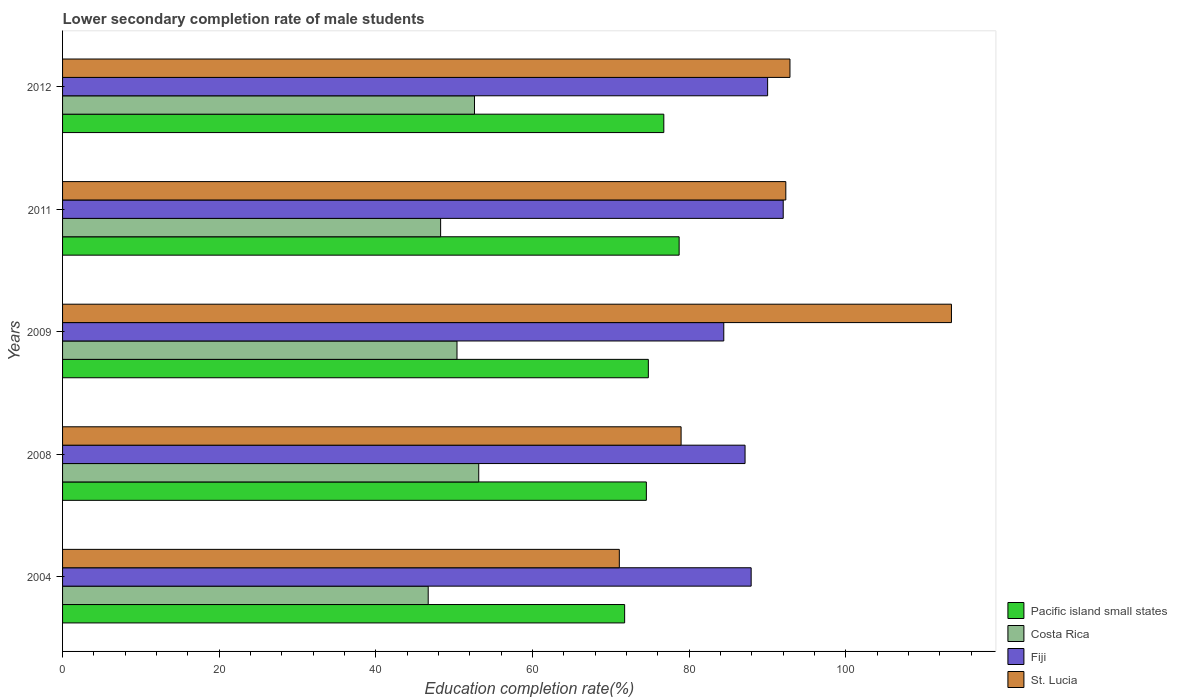How many different coloured bars are there?
Ensure brevity in your answer.  4. How many groups of bars are there?
Offer a very short reply. 5. How many bars are there on the 4th tick from the top?
Your response must be concise. 4. How many bars are there on the 2nd tick from the bottom?
Your answer should be very brief. 4. In how many cases, is the number of bars for a given year not equal to the number of legend labels?
Provide a short and direct response. 0. What is the lower secondary completion rate of male students in Fiji in 2004?
Your response must be concise. 87.9. Across all years, what is the maximum lower secondary completion rate of male students in St. Lucia?
Your answer should be very brief. 113.47. Across all years, what is the minimum lower secondary completion rate of male students in St. Lucia?
Your answer should be compact. 71.07. What is the total lower secondary completion rate of male students in Costa Rica in the graph?
Your answer should be very brief. 251. What is the difference between the lower secondary completion rate of male students in Fiji in 2009 and that in 2011?
Keep it short and to the point. -7.59. What is the difference between the lower secondary completion rate of male students in Fiji in 2004 and the lower secondary completion rate of male students in St. Lucia in 2012?
Your answer should be compact. -4.95. What is the average lower secondary completion rate of male students in Pacific island small states per year?
Provide a succinct answer. 75.3. In the year 2004, what is the difference between the lower secondary completion rate of male students in St. Lucia and lower secondary completion rate of male students in Costa Rica?
Your answer should be compact. 24.4. What is the ratio of the lower secondary completion rate of male students in Fiji in 2004 to that in 2008?
Your answer should be very brief. 1.01. Is the lower secondary completion rate of male students in Pacific island small states in 2008 less than that in 2009?
Your response must be concise. Yes. Is the difference between the lower secondary completion rate of male students in St. Lucia in 2009 and 2011 greater than the difference between the lower secondary completion rate of male students in Costa Rica in 2009 and 2011?
Provide a short and direct response. Yes. What is the difference between the highest and the second highest lower secondary completion rate of male students in Costa Rica?
Ensure brevity in your answer.  0.54. What is the difference between the highest and the lowest lower secondary completion rate of male students in St. Lucia?
Ensure brevity in your answer.  42.4. In how many years, is the lower secondary completion rate of male students in Fiji greater than the average lower secondary completion rate of male students in Fiji taken over all years?
Offer a very short reply. 2. What does the 4th bar from the bottom in 2008 represents?
Provide a short and direct response. St. Lucia. How many years are there in the graph?
Your answer should be compact. 5. Does the graph contain grids?
Your answer should be very brief. No. Where does the legend appear in the graph?
Provide a succinct answer. Bottom right. How many legend labels are there?
Provide a short and direct response. 4. How are the legend labels stacked?
Offer a terse response. Vertical. What is the title of the graph?
Your answer should be compact. Lower secondary completion rate of male students. Does "Sub-Saharan Africa (developing only)" appear as one of the legend labels in the graph?
Offer a terse response. No. What is the label or title of the X-axis?
Your answer should be very brief. Education completion rate(%). What is the Education completion rate(%) in Pacific island small states in 2004?
Offer a terse response. 71.75. What is the Education completion rate(%) in Costa Rica in 2004?
Your answer should be very brief. 46.68. What is the Education completion rate(%) in Fiji in 2004?
Provide a short and direct response. 87.9. What is the Education completion rate(%) of St. Lucia in 2004?
Give a very brief answer. 71.07. What is the Education completion rate(%) of Pacific island small states in 2008?
Your answer should be compact. 74.52. What is the Education completion rate(%) in Costa Rica in 2008?
Give a very brief answer. 53.13. What is the Education completion rate(%) in Fiji in 2008?
Offer a very short reply. 87.12. What is the Education completion rate(%) of St. Lucia in 2008?
Keep it short and to the point. 78.96. What is the Education completion rate(%) in Pacific island small states in 2009?
Make the answer very short. 74.78. What is the Education completion rate(%) of Costa Rica in 2009?
Offer a terse response. 50.35. What is the Education completion rate(%) of Fiji in 2009?
Provide a succinct answer. 84.41. What is the Education completion rate(%) of St. Lucia in 2009?
Offer a terse response. 113.47. What is the Education completion rate(%) of Pacific island small states in 2011?
Your response must be concise. 78.71. What is the Education completion rate(%) of Costa Rica in 2011?
Offer a terse response. 48.26. What is the Education completion rate(%) of Fiji in 2011?
Your response must be concise. 92. What is the Education completion rate(%) of St. Lucia in 2011?
Make the answer very short. 92.33. What is the Education completion rate(%) in Pacific island small states in 2012?
Offer a terse response. 76.75. What is the Education completion rate(%) of Costa Rica in 2012?
Provide a succinct answer. 52.58. What is the Education completion rate(%) of Fiji in 2012?
Keep it short and to the point. 90. What is the Education completion rate(%) of St. Lucia in 2012?
Ensure brevity in your answer.  92.86. Across all years, what is the maximum Education completion rate(%) of Pacific island small states?
Your answer should be very brief. 78.71. Across all years, what is the maximum Education completion rate(%) in Costa Rica?
Your response must be concise. 53.13. Across all years, what is the maximum Education completion rate(%) in Fiji?
Your answer should be compact. 92. Across all years, what is the maximum Education completion rate(%) of St. Lucia?
Provide a succinct answer. 113.47. Across all years, what is the minimum Education completion rate(%) of Pacific island small states?
Make the answer very short. 71.75. Across all years, what is the minimum Education completion rate(%) in Costa Rica?
Your response must be concise. 46.68. Across all years, what is the minimum Education completion rate(%) of Fiji?
Your answer should be compact. 84.41. Across all years, what is the minimum Education completion rate(%) of St. Lucia?
Offer a very short reply. 71.07. What is the total Education completion rate(%) of Pacific island small states in the graph?
Make the answer very short. 376.51. What is the total Education completion rate(%) of Costa Rica in the graph?
Keep it short and to the point. 251. What is the total Education completion rate(%) in Fiji in the graph?
Ensure brevity in your answer.  441.43. What is the total Education completion rate(%) of St. Lucia in the graph?
Ensure brevity in your answer.  448.69. What is the difference between the Education completion rate(%) of Pacific island small states in 2004 and that in 2008?
Offer a very short reply. -2.77. What is the difference between the Education completion rate(%) of Costa Rica in 2004 and that in 2008?
Your response must be concise. -6.45. What is the difference between the Education completion rate(%) in Fiji in 2004 and that in 2008?
Your answer should be compact. 0.78. What is the difference between the Education completion rate(%) of St. Lucia in 2004 and that in 2008?
Offer a very short reply. -7.89. What is the difference between the Education completion rate(%) of Pacific island small states in 2004 and that in 2009?
Make the answer very short. -3.03. What is the difference between the Education completion rate(%) in Costa Rica in 2004 and that in 2009?
Offer a terse response. -3.67. What is the difference between the Education completion rate(%) in Fiji in 2004 and that in 2009?
Your response must be concise. 3.49. What is the difference between the Education completion rate(%) of St. Lucia in 2004 and that in 2009?
Make the answer very short. -42.4. What is the difference between the Education completion rate(%) of Pacific island small states in 2004 and that in 2011?
Provide a short and direct response. -6.96. What is the difference between the Education completion rate(%) in Costa Rica in 2004 and that in 2011?
Provide a succinct answer. -1.59. What is the difference between the Education completion rate(%) in Fiji in 2004 and that in 2011?
Make the answer very short. -4.09. What is the difference between the Education completion rate(%) of St. Lucia in 2004 and that in 2011?
Your answer should be compact. -21.25. What is the difference between the Education completion rate(%) of Pacific island small states in 2004 and that in 2012?
Give a very brief answer. -5. What is the difference between the Education completion rate(%) in Costa Rica in 2004 and that in 2012?
Provide a succinct answer. -5.91. What is the difference between the Education completion rate(%) in Fiji in 2004 and that in 2012?
Make the answer very short. -2.1. What is the difference between the Education completion rate(%) in St. Lucia in 2004 and that in 2012?
Keep it short and to the point. -21.78. What is the difference between the Education completion rate(%) in Pacific island small states in 2008 and that in 2009?
Offer a very short reply. -0.25. What is the difference between the Education completion rate(%) of Costa Rica in 2008 and that in 2009?
Your answer should be compact. 2.78. What is the difference between the Education completion rate(%) of Fiji in 2008 and that in 2009?
Your response must be concise. 2.71. What is the difference between the Education completion rate(%) in St. Lucia in 2008 and that in 2009?
Provide a succinct answer. -34.51. What is the difference between the Education completion rate(%) in Pacific island small states in 2008 and that in 2011?
Your response must be concise. -4.19. What is the difference between the Education completion rate(%) in Costa Rica in 2008 and that in 2011?
Ensure brevity in your answer.  4.86. What is the difference between the Education completion rate(%) in Fiji in 2008 and that in 2011?
Your answer should be compact. -4.87. What is the difference between the Education completion rate(%) in St. Lucia in 2008 and that in 2011?
Your response must be concise. -13.37. What is the difference between the Education completion rate(%) in Pacific island small states in 2008 and that in 2012?
Your answer should be compact. -2.23. What is the difference between the Education completion rate(%) in Costa Rica in 2008 and that in 2012?
Make the answer very short. 0.54. What is the difference between the Education completion rate(%) of Fiji in 2008 and that in 2012?
Your answer should be compact. -2.88. What is the difference between the Education completion rate(%) of St. Lucia in 2008 and that in 2012?
Your response must be concise. -13.9. What is the difference between the Education completion rate(%) in Pacific island small states in 2009 and that in 2011?
Provide a succinct answer. -3.93. What is the difference between the Education completion rate(%) in Costa Rica in 2009 and that in 2011?
Provide a succinct answer. 2.09. What is the difference between the Education completion rate(%) in Fiji in 2009 and that in 2011?
Your answer should be very brief. -7.59. What is the difference between the Education completion rate(%) of St. Lucia in 2009 and that in 2011?
Give a very brief answer. 21.15. What is the difference between the Education completion rate(%) of Pacific island small states in 2009 and that in 2012?
Offer a terse response. -1.98. What is the difference between the Education completion rate(%) of Costa Rica in 2009 and that in 2012?
Provide a short and direct response. -2.23. What is the difference between the Education completion rate(%) of Fiji in 2009 and that in 2012?
Provide a short and direct response. -5.6. What is the difference between the Education completion rate(%) of St. Lucia in 2009 and that in 2012?
Your answer should be compact. 20.61. What is the difference between the Education completion rate(%) of Pacific island small states in 2011 and that in 2012?
Your answer should be very brief. 1.96. What is the difference between the Education completion rate(%) of Costa Rica in 2011 and that in 2012?
Ensure brevity in your answer.  -4.32. What is the difference between the Education completion rate(%) of Fiji in 2011 and that in 2012?
Ensure brevity in your answer.  1.99. What is the difference between the Education completion rate(%) of St. Lucia in 2011 and that in 2012?
Your response must be concise. -0.53. What is the difference between the Education completion rate(%) of Pacific island small states in 2004 and the Education completion rate(%) of Costa Rica in 2008?
Offer a terse response. 18.62. What is the difference between the Education completion rate(%) in Pacific island small states in 2004 and the Education completion rate(%) in Fiji in 2008?
Give a very brief answer. -15.37. What is the difference between the Education completion rate(%) of Pacific island small states in 2004 and the Education completion rate(%) of St. Lucia in 2008?
Your answer should be very brief. -7.21. What is the difference between the Education completion rate(%) in Costa Rica in 2004 and the Education completion rate(%) in Fiji in 2008?
Provide a succinct answer. -40.45. What is the difference between the Education completion rate(%) of Costa Rica in 2004 and the Education completion rate(%) of St. Lucia in 2008?
Provide a short and direct response. -32.28. What is the difference between the Education completion rate(%) of Fiji in 2004 and the Education completion rate(%) of St. Lucia in 2008?
Ensure brevity in your answer.  8.94. What is the difference between the Education completion rate(%) of Pacific island small states in 2004 and the Education completion rate(%) of Costa Rica in 2009?
Offer a very short reply. 21.4. What is the difference between the Education completion rate(%) in Pacific island small states in 2004 and the Education completion rate(%) in Fiji in 2009?
Keep it short and to the point. -12.66. What is the difference between the Education completion rate(%) of Pacific island small states in 2004 and the Education completion rate(%) of St. Lucia in 2009?
Give a very brief answer. -41.72. What is the difference between the Education completion rate(%) of Costa Rica in 2004 and the Education completion rate(%) of Fiji in 2009?
Provide a short and direct response. -37.73. What is the difference between the Education completion rate(%) in Costa Rica in 2004 and the Education completion rate(%) in St. Lucia in 2009?
Offer a terse response. -66.8. What is the difference between the Education completion rate(%) in Fiji in 2004 and the Education completion rate(%) in St. Lucia in 2009?
Ensure brevity in your answer.  -25.57. What is the difference between the Education completion rate(%) in Pacific island small states in 2004 and the Education completion rate(%) in Costa Rica in 2011?
Offer a terse response. 23.49. What is the difference between the Education completion rate(%) in Pacific island small states in 2004 and the Education completion rate(%) in Fiji in 2011?
Offer a terse response. -20.24. What is the difference between the Education completion rate(%) of Pacific island small states in 2004 and the Education completion rate(%) of St. Lucia in 2011?
Your response must be concise. -20.57. What is the difference between the Education completion rate(%) in Costa Rica in 2004 and the Education completion rate(%) in Fiji in 2011?
Offer a very short reply. -45.32. What is the difference between the Education completion rate(%) in Costa Rica in 2004 and the Education completion rate(%) in St. Lucia in 2011?
Provide a succinct answer. -45.65. What is the difference between the Education completion rate(%) of Fiji in 2004 and the Education completion rate(%) of St. Lucia in 2011?
Give a very brief answer. -4.42. What is the difference between the Education completion rate(%) of Pacific island small states in 2004 and the Education completion rate(%) of Costa Rica in 2012?
Offer a very short reply. 19.17. What is the difference between the Education completion rate(%) of Pacific island small states in 2004 and the Education completion rate(%) of Fiji in 2012?
Provide a succinct answer. -18.25. What is the difference between the Education completion rate(%) in Pacific island small states in 2004 and the Education completion rate(%) in St. Lucia in 2012?
Provide a short and direct response. -21.11. What is the difference between the Education completion rate(%) in Costa Rica in 2004 and the Education completion rate(%) in Fiji in 2012?
Ensure brevity in your answer.  -43.33. What is the difference between the Education completion rate(%) in Costa Rica in 2004 and the Education completion rate(%) in St. Lucia in 2012?
Your answer should be compact. -46.18. What is the difference between the Education completion rate(%) of Fiji in 2004 and the Education completion rate(%) of St. Lucia in 2012?
Ensure brevity in your answer.  -4.95. What is the difference between the Education completion rate(%) in Pacific island small states in 2008 and the Education completion rate(%) in Costa Rica in 2009?
Your response must be concise. 24.17. What is the difference between the Education completion rate(%) of Pacific island small states in 2008 and the Education completion rate(%) of Fiji in 2009?
Your answer should be compact. -9.89. What is the difference between the Education completion rate(%) in Pacific island small states in 2008 and the Education completion rate(%) in St. Lucia in 2009?
Keep it short and to the point. -38.95. What is the difference between the Education completion rate(%) of Costa Rica in 2008 and the Education completion rate(%) of Fiji in 2009?
Your answer should be very brief. -31.28. What is the difference between the Education completion rate(%) in Costa Rica in 2008 and the Education completion rate(%) in St. Lucia in 2009?
Your answer should be very brief. -60.34. What is the difference between the Education completion rate(%) in Fiji in 2008 and the Education completion rate(%) in St. Lucia in 2009?
Your response must be concise. -26.35. What is the difference between the Education completion rate(%) of Pacific island small states in 2008 and the Education completion rate(%) of Costa Rica in 2011?
Ensure brevity in your answer.  26.26. What is the difference between the Education completion rate(%) in Pacific island small states in 2008 and the Education completion rate(%) in Fiji in 2011?
Offer a terse response. -17.47. What is the difference between the Education completion rate(%) of Pacific island small states in 2008 and the Education completion rate(%) of St. Lucia in 2011?
Provide a succinct answer. -17.8. What is the difference between the Education completion rate(%) in Costa Rica in 2008 and the Education completion rate(%) in Fiji in 2011?
Provide a succinct answer. -38.87. What is the difference between the Education completion rate(%) of Costa Rica in 2008 and the Education completion rate(%) of St. Lucia in 2011?
Provide a short and direct response. -39.2. What is the difference between the Education completion rate(%) of Fiji in 2008 and the Education completion rate(%) of St. Lucia in 2011?
Provide a succinct answer. -5.2. What is the difference between the Education completion rate(%) in Pacific island small states in 2008 and the Education completion rate(%) in Costa Rica in 2012?
Offer a terse response. 21.94. What is the difference between the Education completion rate(%) of Pacific island small states in 2008 and the Education completion rate(%) of Fiji in 2012?
Offer a terse response. -15.48. What is the difference between the Education completion rate(%) in Pacific island small states in 2008 and the Education completion rate(%) in St. Lucia in 2012?
Your answer should be compact. -18.33. What is the difference between the Education completion rate(%) in Costa Rica in 2008 and the Education completion rate(%) in Fiji in 2012?
Ensure brevity in your answer.  -36.88. What is the difference between the Education completion rate(%) in Costa Rica in 2008 and the Education completion rate(%) in St. Lucia in 2012?
Provide a succinct answer. -39.73. What is the difference between the Education completion rate(%) in Fiji in 2008 and the Education completion rate(%) in St. Lucia in 2012?
Give a very brief answer. -5.73. What is the difference between the Education completion rate(%) in Pacific island small states in 2009 and the Education completion rate(%) in Costa Rica in 2011?
Your answer should be very brief. 26.52. What is the difference between the Education completion rate(%) in Pacific island small states in 2009 and the Education completion rate(%) in Fiji in 2011?
Ensure brevity in your answer.  -17.22. What is the difference between the Education completion rate(%) of Pacific island small states in 2009 and the Education completion rate(%) of St. Lucia in 2011?
Your response must be concise. -17.55. What is the difference between the Education completion rate(%) in Costa Rica in 2009 and the Education completion rate(%) in Fiji in 2011?
Keep it short and to the point. -41.64. What is the difference between the Education completion rate(%) of Costa Rica in 2009 and the Education completion rate(%) of St. Lucia in 2011?
Ensure brevity in your answer.  -41.97. What is the difference between the Education completion rate(%) of Fiji in 2009 and the Education completion rate(%) of St. Lucia in 2011?
Provide a succinct answer. -7.92. What is the difference between the Education completion rate(%) of Pacific island small states in 2009 and the Education completion rate(%) of Costa Rica in 2012?
Your answer should be compact. 22.19. What is the difference between the Education completion rate(%) of Pacific island small states in 2009 and the Education completion rate(%) of Fiji in 2012?
Give a very brief answer. -15.23. What is the difference between the Education completion rate(%) in Pacific island small states in 2009 and the Education completion rate(%) in St. Lucia in 2012?
Provide a succinct answer. -18.08. What is the difference between the Education completion rate(%) of Costa Rica in 2009 and the Education completion rate(%) of Fiji in 2012?
Offer a very short reply. -39.65. What is the difference between the Education completion rate(%) in Costa Rica in 2009 and the Education completion rate(%) in St. Lucia in 2012?
Keep it short and to the point. -42.51. What is the difference between the Education completion rate(%) of Fiji in 2009 and the Education completion rate(%) of St. Lucia in 2012?
Offer a terse response. -8.45. What is the difference between the Education completion rate(%) in Pacific island small states in 2011 and the Education completion rate(%) in Costa Rica in 2012?
Your answer should be compact. 26.12. What is the difference between the Education completion rate(%) in Pacific island small states in 2011 and the Education completion rate(%) in Fiji in 2012?
Keep it short and to the point. -11.29. What is the difference between the Education completion rate(%) in Pacific island small states in 2011 and the Education completion rate(%) in St. Lucia in 2012?
Offer a terse response. -14.15. What is the difference between the Education completion rate(%) in Costa Rica in 2011 and the Education completion rate(%) in Fiji in 2012?
Your answer should be very brief. -41.74. What is the difference between the Education completion rate(%) in Costa Rica in 2011 and the Education completion rate(%) in St. Lucia in 2012?
Keep it short and to the point. -44.59. What is the difference between the Education completion rate(%) in Fiji in 2011 and the Education completion rate(%) in St. Lucia in 2012?
Offer a very short reply. -0.86. What is the average Education completion rate(%) of Pacific island small states per year?
Ensure brevity in your answer.  75.3. What is the average Education completion rate(%) of Costa Rica per year?
Provide a succinct answer. 50.2. What is the average Education completion rate(%) in Fiji per year?
Keep it short and to the point. 88.29. What is the average Education completion rate(%) of St. Lucia per year?
Keep it short and to the point. 89.74. In the year 2004, what is the difference between the Education completion rate(%) of Pacific island small states and Education completion rate(%) of Costa Rica?
Your response must be concise. 25.08. In the year 2004, what is the difference between the Education completion rate(%) of Pacific island small states and Education completion rate(%) of Fiji?
Keep it short and to the point. -16.15. In the year 2004, what is the difference between the Education completion rate(%) of Pacific island small states and Education completion rate(%) of St. Lucia?
Provide a succinct answer. 0.68. In the year 2004, what is the difference between the Education completion rate(%) of Costa Rica and Education completion rate(%) of Fiji?
Your response must be concise. -41.23. In the year 2004, what is the difference between the Education completion rate(%) in Costa Rica and Education completion rate(%) in St. Lucia?
Offer a terse response. -24.4. In the year 2004, what is the difference between the Education completion rate(%) in Fiji and Education completion rate(%) in St. Lucia?
Your answer should be very brief. 16.83. In the year 2008, what is the difference between the Education completion rate(%) in Pacific island small states and Education completion rate(%) in Costa Rica?
Give a very brief answer. 21.4. In the year 2008, what is the difference between the Education completion rate(%) in Pacific island small states and Education completion rate(%) in St. Lucia?
Your answer should be very brief. -4.44. In the year 2008, what is the difference between the Education completion rate(%) of Costa Rica and Education completion rate(%) of Fiji?
Your response must be concise. -34. In the year 2008, what is the difference between the Education completion rate(%) of Costa Rica and Education completion rate(%) of St. Lucia?
Make the answer very short. -25.83. In the year 2008, what is the difference between the Education completion rate(%) in Fiji and Education completion rate(%) in St. Lucia?
Ensure brevity in your answer.  8.16. In the year 2009, what is the difference between the Education completion rate(%) in Pacific island small states and Education completion rate(%) in Costa Rica?
Offer a terse response. 24.43. In the year 2009, what is the difference between the Education completion rate(%) in Pacific island small states and Education completion rate(%) in Fiji?
Make the answer very short. -9.63. In the year 2009, what is the difference between the Education completion rate(%) in Pacific island small states and Education completion rate(%) in St. Lucia?
Your response must be concise. -38.69. In the year 2009, what is the difference between the Education completion rate(%) of Costa Rica and Education completion rate(%) of Fiji?
Your answer should be compact. -34.06. In the year 2009, what is the difference between the Education completion rate(%) in Costa Rica and Education completion rate(%) in St. Lucia?
Offer a terse response. -63.12. In the year 2009, what is the difference between the Education completion rate(%) of Fiji and Education completion rate(%) of St. Lucia?
Make the answer very short. -29.06. In the year 2011, what is the difference between the Education completion rate(%) of Pacific island small states and Education completion rate(%) of Costa Rica?
Make the answer very short. 30.45. In the year 2011, what is the difference between the Education completion rate(%) of Pacific island small states and Education completion rate(%) of Fiji?
Your answer should be compact. -13.29. In the year 2011, what is the difference between the Education completion rate(%) in Pacific island small states and Education completion rate(%) in St. Lucia?
Your answer should be very brief. -13.62. In the year 2011, what is the difference between the Education completion rate(%) of Costa Rica and Education completion rate(%) of Fiji?
Make the answer very short. -43.73. In the year 2011, what is the difference between the Education completion rate(%) in Costa Rica and Education completion rate(%) in St. Lucia?
Offer a terse response. -44.06. In the year 2011, what is the difference between the Education completion rate(%) of Fiji and Education completion rate(%) of St. Lucia?
Ensure brevity in your answer.  -0.33. In the year 2012, what is the difference between the Education completion rate(%) in Pacific island small states and Education completion rate(%) in Costa Rica?
Keep it short and to the point. 24.17. In the year 2012, what is the difference between the Education completion rate(%) of Pacific island small states and Education completion rate(%) of Fiji?
Your answer should be very brief. -13.25. In the year 2012, what is the difference between the Education completion rate(%) in Pacific island small states and Education completion rate(%) in St. Lucia?
Offer a very short reply. -16.1. In the year 2012, what is the difference between the Education completion rate(%) in Costa Rica and Education completion rate(%) in Fiji?
Your answer should be very brief. -37.42. In the year 2012, what is the difference between the Education completion rate(%) of Costa Rica and Education completion rate(%) of St. Lucia?
Make the answer very short. -40.27. In the year 2012, what is the difference between the Education completion rate(%) in Fiji and Education completion rate(%) in St. Lucia?
Keep it short and to the point. -2.85. What is the ratio of the Education completion rate(%) of Pacific island small states in 2004 to that in 2008?
Give a very brief answer. 0.96. What is the ratio of the Education completion rate(%) of Costa Rica in 2004 to that in 2008?
Ensure brevity in your answer.  0.88. What is the ratio of the Education completion rate(%) in Fiji in 2004 to that in 2008?
Your answer should be compact. 1.01. What is the ratio of the Education completion rate(%) in St. Lucia in 2004 to that in 2008?
Your answer should be compact. 0.9. What is the ratio of the Education completion rate(%) of Pacific island small states in 2004 to that in 2009?
Provide a short and direct response. 0.96. What is the ratio of the Education completion rate(%) of Costa Rica in 2004 to that in 2009?
Ensure brevity in your answer.  0.93. What is the ratio of the Education completion rate(%) in Fiji in 2004 to that in 2009?
Provide a short and direct response. 1.04. What is the ratio of the Education completion rate(%) of St. Lucia in 2004 to that in 2009?
Your answer should be compact. 0.63. What is the ratio of the Education completion rate(%) of Pacific island small states in 2004 to that in 2011?
Ensure brevity in your answer.  0.91. What is the ratio of the Education completion rate(%) in Costa Rica in 2004 to that in 2011?
Provide a succinct answer. 0.97. What is the ratio of the Education completion rate(%) in Fiji in 2004 to that in 2011?
Provide a succinct answer. 0.96. What is the ratio of the Education completion rate(%) of St. Lucia in 2004 to that in 2011?
Your response must be concise. 0.77. What is the ratio of the Education completion rate(%) of Pacific island small states in 2004 to that in 2012?
Keep it short and to the point. 0.93. What is the ratio of the Education completion rate(%) of Costa Rica in 2004 to that in 2012?
Your answer should be very brief. 0.89. What is the ratio of the Education completion rate(%) of Fiji in 2004 to that in 2012?
Give a very brief answer. 0.98. What is the ratio of the Education completion rate(%) of St. Lucia in 2004 to that in 2012?
Your answer should be compact. 0.77. What is the ratio of the Education completion rate(%) in Pacific island small states in 2008 to that in 2009?
Provide a succinct answer. 1. What is the ratio of the Education completion rate(%) of Costa Rica in 2008 to that in 2009?
Make the answer very short. 1.06. What is the ratio of the Education completion rate(%) in Fiji in 2008 to that in 2009?
Give a very brief answer. 1.03. What is the ratio of the Education completion rate(%) of St. Lucia in 2008 to that in 2009?
Offer a terse response. 0.7. What is the ratio of the Education completion rate(%) in Pacific island small states in 2008 to that in 2011?
Provide a succinct answer. 0.95. What is the ratio of the Education completion rate(%) of Costa Rica in 2008 to that in 2011?
Make the answer very short. 1.1. What is the ratio of the Education completion rate(%) of Fiji in 2008 to that in 2011?
Your answer should be compact. 0.95. What is the ratio of the Education completion rate(%) of St. Lucia in 2008 to that in 2011?
Your answer should be very brief. 0.86. What is the ratio of the Education completion rate(%) in Costa Rica in 2008 to that in 2012?
Make the answer very short. 1.01. What is the ratio of the Education completion rate(%) of Fiji in 2008 to that in 2012?
Keep it short and to the point. 0.97. What is the ratio of the Education completion rate(%) in St. Lucia in 2008 to that in 2012?
Your response must be concise. 0.85. What is the ratio of the Education completion rate(%) of Pacific island small states in 2009 to that in 2011?
Your response must be concise. 0.95. What is the ratio of the Education completion rate(%) of Costa Rica in 2009 to that in 2011?
Your answer should be compact. 1.04. What is the ratio of the Education completion rate(%) of Fiji in 2009 to that in 2011?
Provide a succinct answer. 0.92. What is the ratio of the Education completion rate(%) of St. Lucia in 2009 to that in 2011?
Give a very brief answer. 1.23. What is the ratio of the Education completion rate(%) of Pacific island small states in 2009 to that in 2012?
Your response must be concise. 0.97. What is the ratio of the Education completion rate(%) of Costa Rica in 2009 to that in 2012?
Your response must be concise. 0.96. What is the ratio of the Education completion rate(%) in Fiji in 2009 to that in 2012?
Ensure brevity in your answer.  0.94. What is the ratio of the Education completion rate(%) in St. Lucia in 2009 to that in 2012?
Provide a short and direct response. 1.22. What is the ratio of the Education completion rate(%) in Pacific island small states in 2011 to that in 2012?
Give a very brief answer. 1.03. What is the ratio of the Education completion rate(%) in Costa Rica in 2011 to that in 2012?
Give a very brief answer. 0.92. What is the ratio of the Education completion rate(%) in Fiji in 2011 to that in 2012?
Give a very brief answer. 1.02. What is the ratio of the Education completion rate(%) in St. Lucia in 2011 to that in 2012?
Give a very brief answer. 0.99. What is the difference between the highest and the second highest Education completion rate(%) of Pacific island small states?
Your answer should be compact. 1.96. What is the difference between the highest and the second highest Education completion rate(%) in Costa Rica?
Your answer should be very brief. 0.54. What is the difference between the highest and the second highest Education completion rate(%) of Fiji?
Your response must be concise. 1.99. What is the difference between the highest and the second highest Education completion rate(%) of St. Lucia?
Keep it short and to the point. 20.61. What is the difference between the highest and the lowest Education completion rate(%) of Pacific island small states?
Your answer should be compact. 6.96. What is the difference between the highest and the lowest Education completion rate(%) of Costa Rica?
Keep it short and to the point. 6.45. What is the difference between the highest and the lowest Education completion rate(%) of Fiji?
Offer a very short reply. 7.59. What is the difference between the highest and the lowest Education completion rate(%) in St. Lucia?
Offer a terse response. 42.4. 